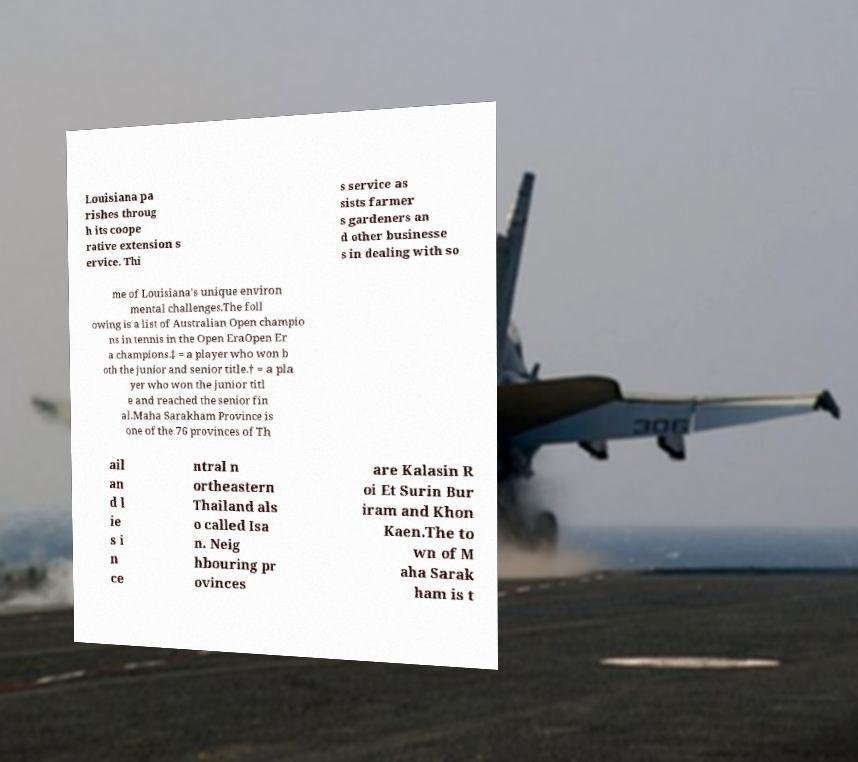Could you assist in decoding the text presented in this image and type it out clearly? Louisiana pa rishes throug h its coope rative extension s ervice. Thi s service as sists farmer s gardeners an d other businesse s in dealing with so me of Louisiana's unique environ mental challenges.The foll owing is a list of Australian Open champio ns in tennis in the Open EraOpen Er a champions.‡ = a player who won b oth the junior and senior title.† = a pla yer who won the junior titl e and reached the senior fin al.Maha Sarakham Province is one of the 76 provinces of Th ail an d l ie s i n ce ntral n ortheastern Thailand als o called Isa n. Neig hbouring pr ovinces are Kalasin R oi Et Surin Bur iram and Khon Kaen.The to wn of M aha Sarak ham is t 